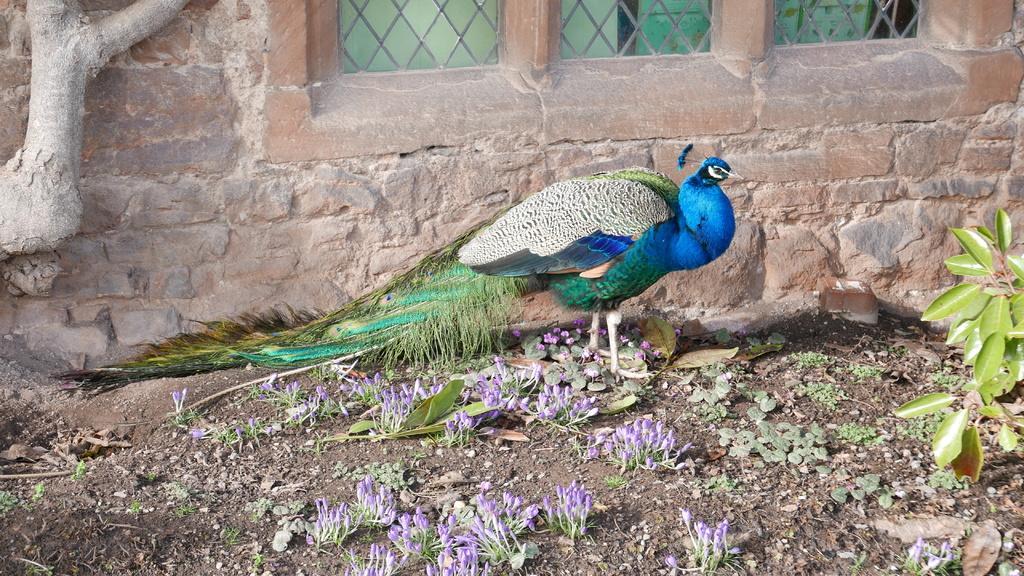In one or two sentences, can you explain what this image depicts? In this image there is a peacock. Behind the peacock there's a wall. There are windows. On the right side of the image there is a plant. At the bottom of the image there are flowers. 